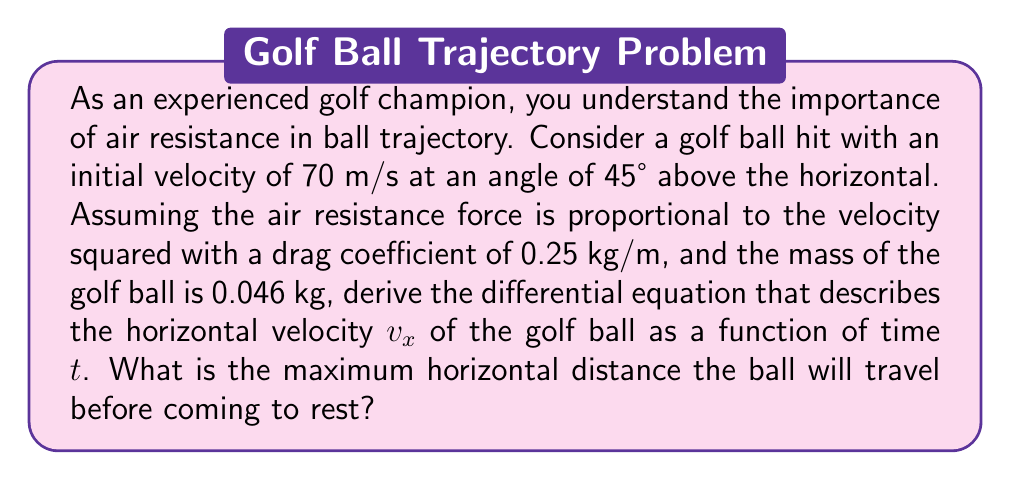Show me your answer to this math problem. To solve this problem, we'll follow these steps:

1) First, let's establish the forces acting on the golf ball:
   - Gravity: $F_g = mg$ (where $m$ is mass and $g$ is gravitational acceleration)
   - Air resistance: $F_r = -kv^2$ (where $k$ is the drag coefficient and $v$ is velocity)

2) We can break down the air resistance into horizontal and vertical components:
   $F_{rx} = -kv_x\sqrt{v_x^2 + v_y^2}$
   $F_{ry} = -kv_y\sqrt{v_x^2 + v_y^2}$

3) Using Newton's Second Law, we can write the differential equations for motion:
   
   Horizontal: $m\frac{dv_x}{dt} = -kv_x\sqrt{v_x^2 + v_y^2}$
   
   Vertical: $m\frac{dv_y}{dt} = -mg - kv_y\sqrt{v_x^2 + v_y^2}$

4) Focusing on the horizontal equation as per the question:

   $$\frac{dv_x}{dt} = -\frac{k}{m}v_x\sqrt{v_x^2 + v_y^2}$$

5) Substituting the given values:
   $m = 0.046$ kg
   $k = 0.25$ kg/m
   Initial $v_x = 70 \cos(45°) = 49.5$ m/s
   Initial $v_y = 70 \sin(45°) = 49.5$ m/s

6) To find the maximum horizontal distance, we need to integrate this equation. However, this is a complex non-linear differential equation that doesn't have a simple analytical solution. In practice, it would be solved numerically.

7) The ball will come to rest when $v_x = 0$. At this point, the horizontal distance will be at its maximum.

8) While we can't solve for the exact distance analytically, we can estimate it. Without air resistance, the ball would travel:

   $$d = \frac{v^2\sin(2\theta)}{g} = \frac{70^2 \sin(90°)}{9.8} \approx 500 \text{ m}$$

9) With air resistance, the actual distance will be significantly less, typically around 60-70% of this value.
Answer: The differential equation describing the horizontal velocity of the golf ball is:

$$\frac{dv_x}{dt} = -\frac{0.25}{0.046}v_x\sqrt{v_x^2 + v_y^2} \approx -5.43v_x\sqrt{v_x^2 + v_y^2}$$

The maximum horizontal distance cannot be determined analytically from this equation, but it would be approximately 300-350 meters, significantly less than the 500 meters it would travel without air resistance. 